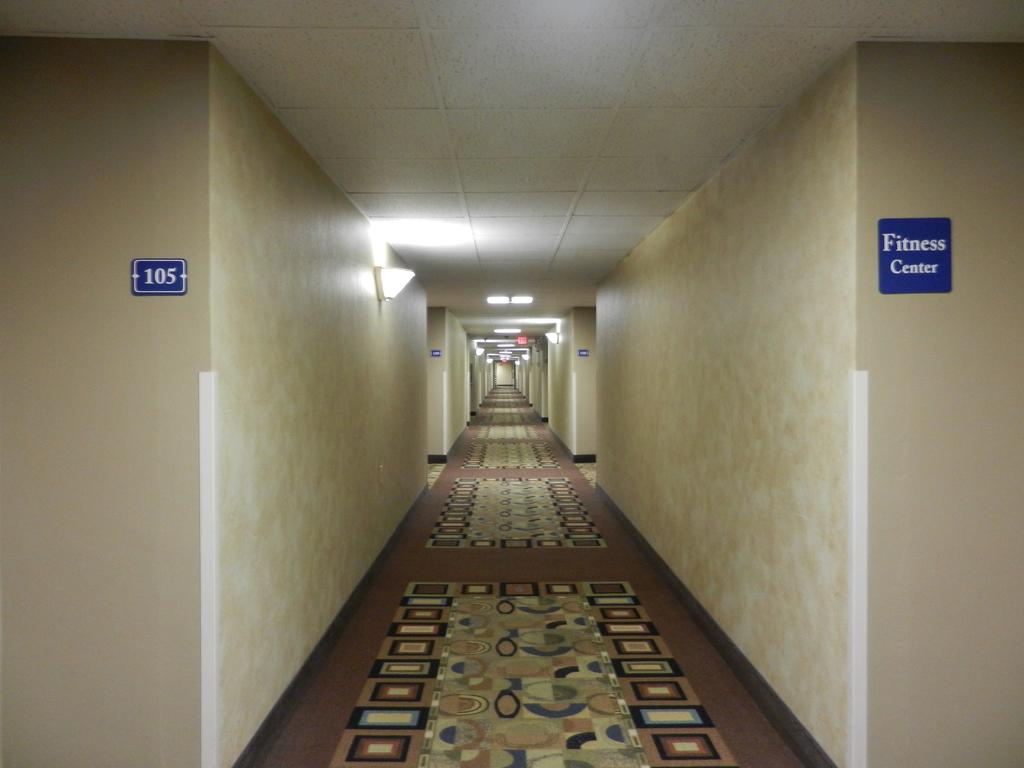What type of structure can be seen in the image? There is a wall in the image. What object is present on the wall? There is a board on the wall. What can be seen illuminating the area in the image? There are lights in the image. Where might this image have been taken? The image may have been taken in a building, given the presence of a wall and a board. What type of leather material is used to join the wall and the board in the image? There is no leather material or any visible joining between the wall and the board in the image. 